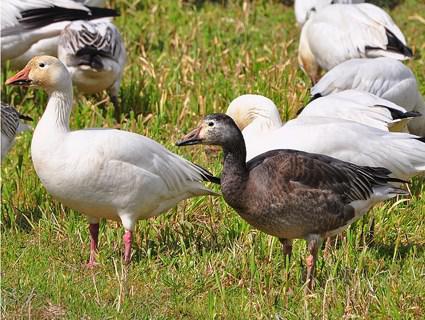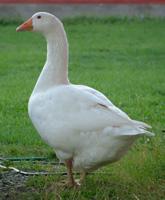The first image is the image on the left, the second image is the image on the right. Given the left and right images, does the statement "There is a single goose in the right image." hold true? Answer yes or no. Yes. The first image is the image on the left, the second image is the image on the right. Given the left and right images, does the statement "There are more than ten geese in the images." hold true? Answer yes or no. No. 